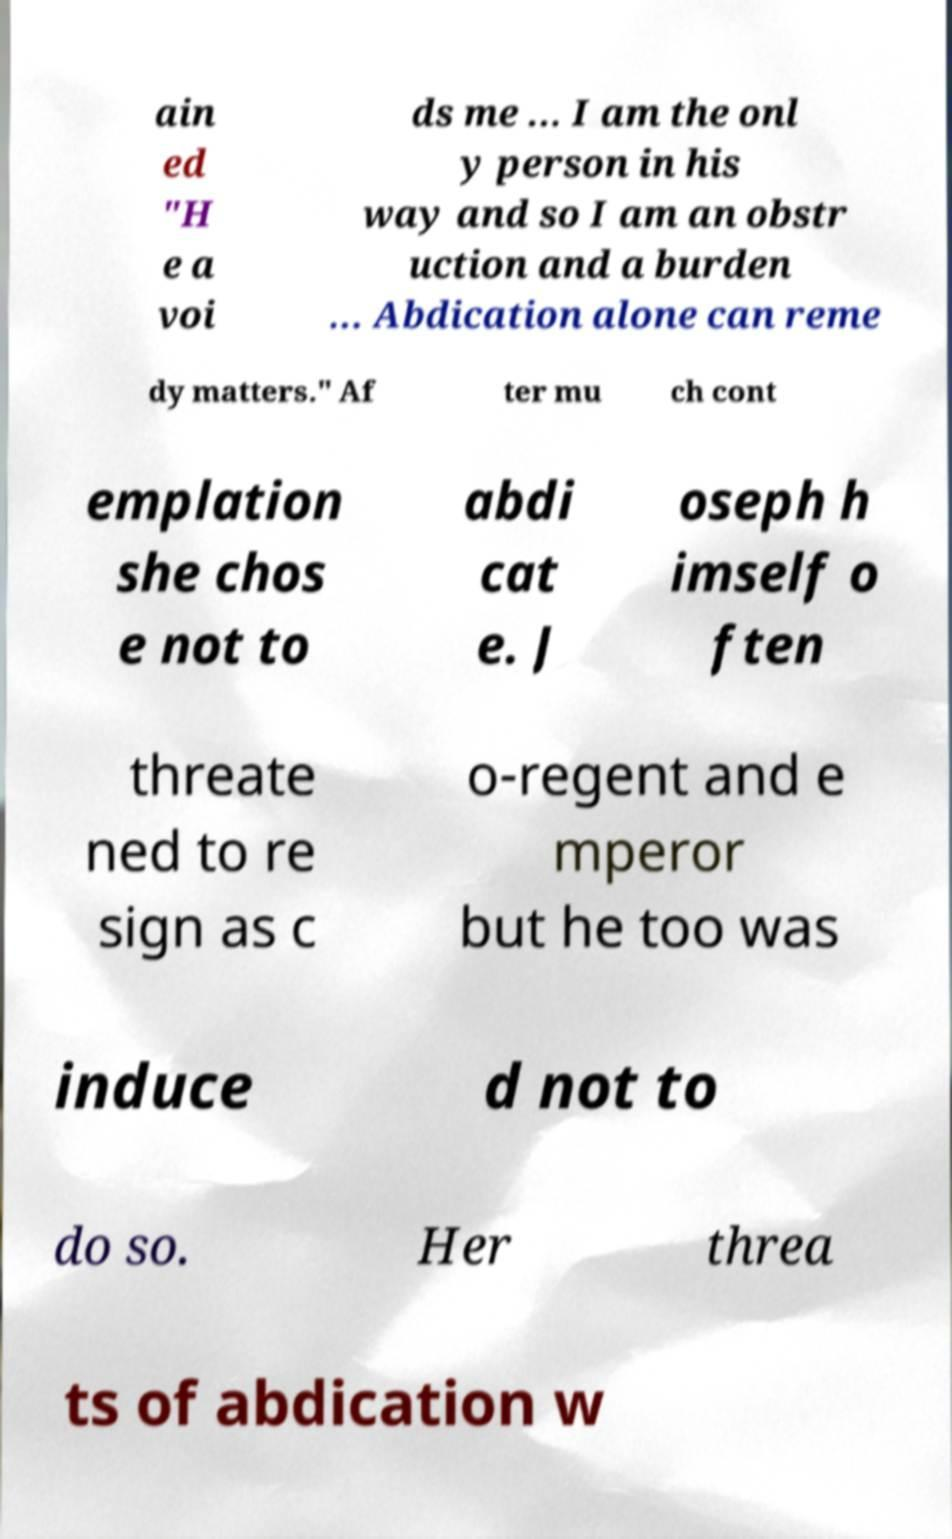Could you assist in decoding the text presented in this image and type it out clearly? ain ed "H e a voi ds me ... I am the onl y person in his way and so I am an obstr uction and a burden ... Abdication alone can reme dy matters." Af ter mu ch cont emplation she chos e not to abdi cat e. J oseph h imself o ften threate ned to re sign as c o-regent and e mperor but he too was induce d not to do so. Her threa ts of abdication w 